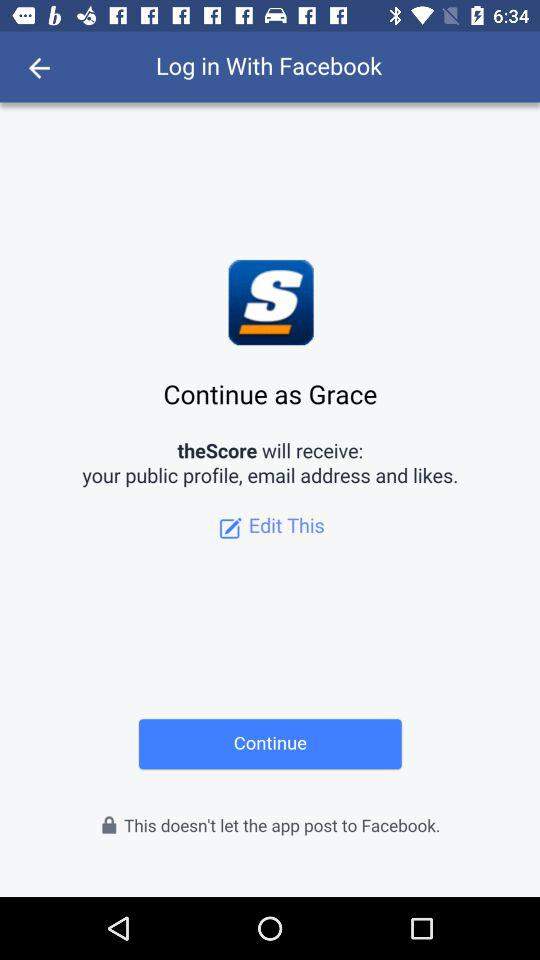What application can be used to log in to the profile? The application is "Facebook". 